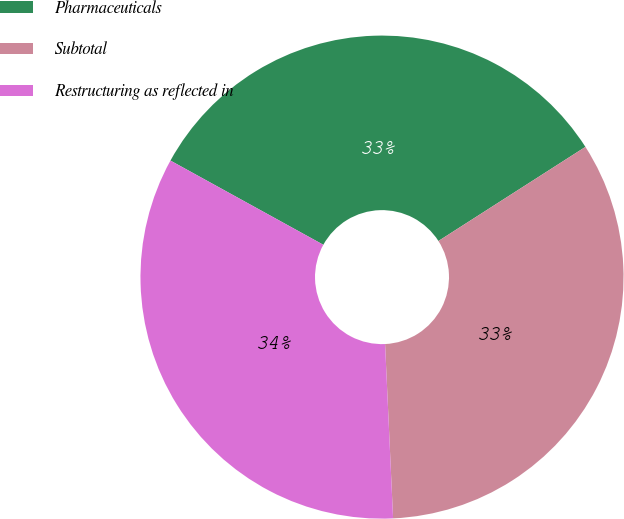Convert chart to OTSL. <chart><loc_0><loc_0><loc_500><loc_500><pie_chart><fcel>Pharmaceuticals<fcel>Subtotal<fcel>Restructuring as reflected in<nl><fcel>32.92%<fcel>33.33%<fcel>33.74%<nl></chart> 